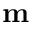<formula> <loc_0><loc_0><loc_500><loc_500>m</formula> 